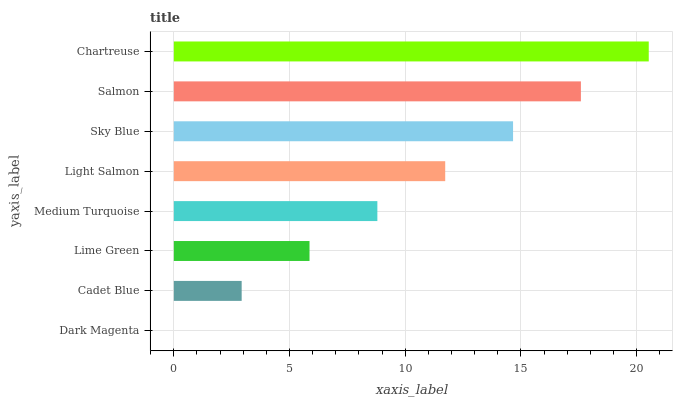Is Dark Magenta the minimum?
Answer yes or no. Yes. Is Chartreuse the maximum?
Answer yes or no. Yes. Is Cadet Blue the minimum?
Answer yes or no. No. Is Cadet Blue the maximum?
Answer yes or no. No. Is Cadet Blue greater than Dark Magenta?
Answer yes or no. Yes. Is Dark Magenta less than Cadet Blue?
Answer yes or no. Yes. Is Dark Magenta greater than Cadet Blue?
Answer yes or no. No. Is Cadet Blue less than Dark Magenta?
Answer yes or no. No. Is Light Salmon the high median?
Answer yes or no. Yes. Is Medium Turquoise the low median?
Answer yes or no. Yes. Is Medium Turquoise the high median?
Answer yes or no. No. Is Salmon the low median?
Answer yes or no. No. 